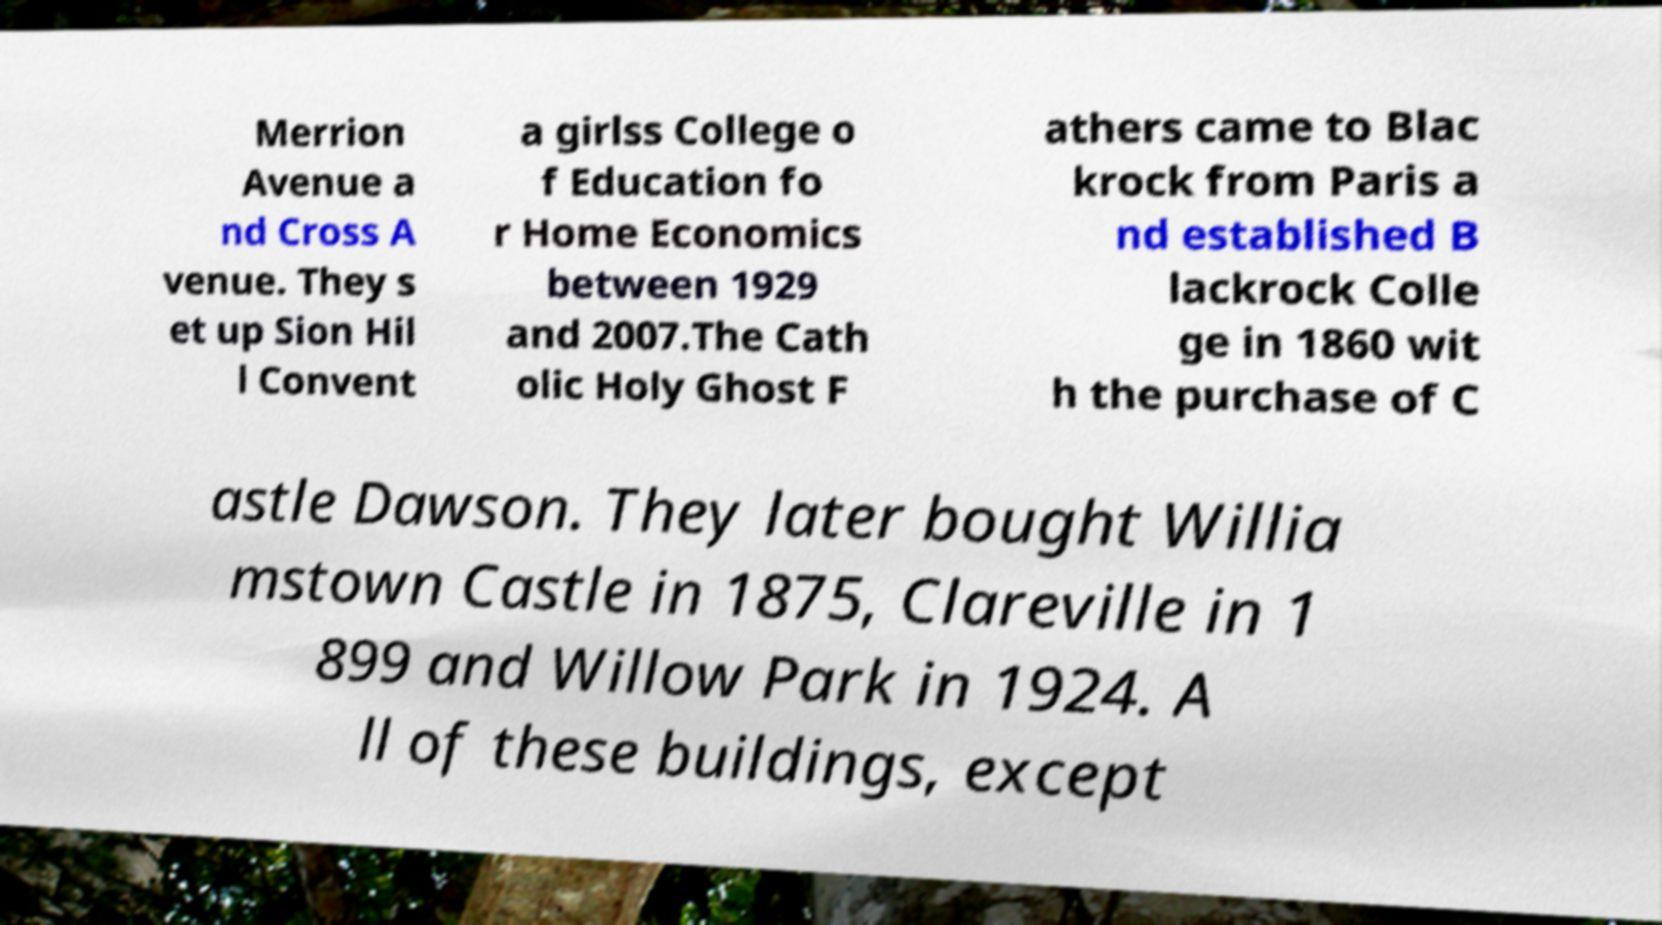Can you read and provide the text displayed in the image?This photo seems to have some interesting text. Can you extract and type it out for me? Merrion Avenue a nd Cross A venue. They s et up Sion Hil l Convent a girlss College o f Education fo r Home Economics between 1929 and 2007.The Cath olic Holy Ghost F athers came to Blac krock from Paris a nd established B lackrock Colle ge in 1860 wit h the purchase of C astle Dawson. They later bought Willia mstown Castle in 1875, Clareville in 1 899 and Willow Park in 1924. A ll of these buildings, except 